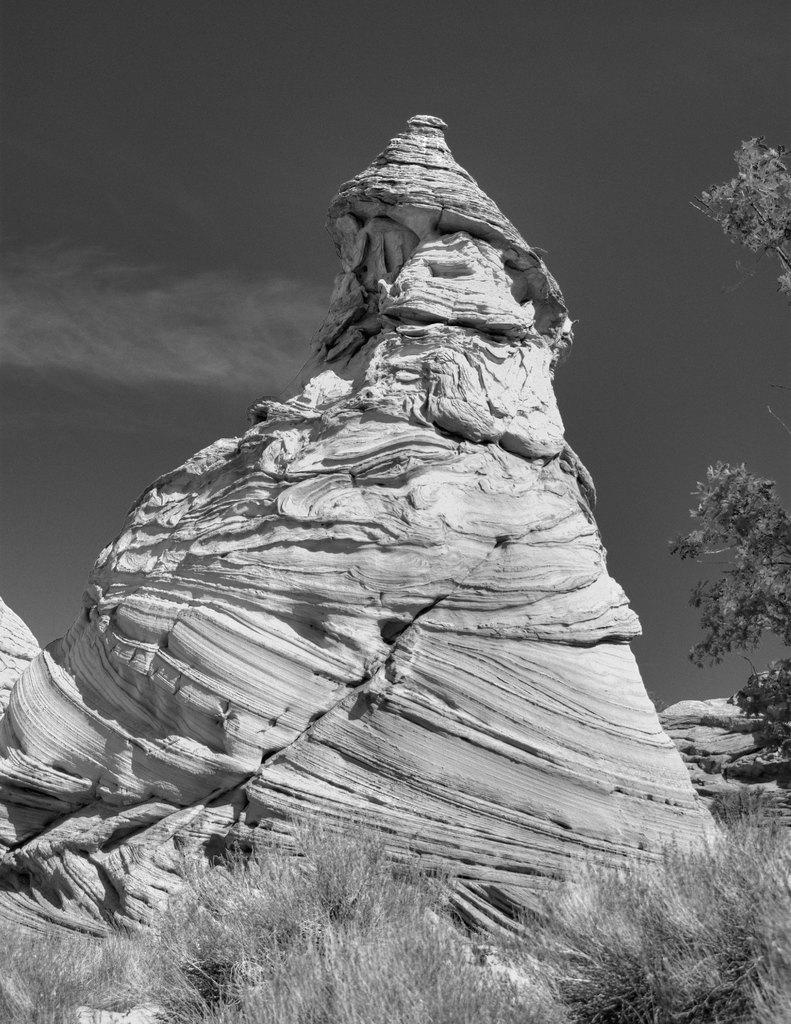What type of vegetation can be seen in the image? There is grass, plants, and trees in the image. What type of landscape is visible in the image? There are mountains in the image. What part of the natural environment is visible in the image? The sky is visible in the image. Can you describe the time of day the image may have been taken? The image may have been taken during the night, as there is no visible sunlight. What type of shirt is the mountain wearing in the image? There are no shirts or clothing items present in the image, as the subject is a mountain. 